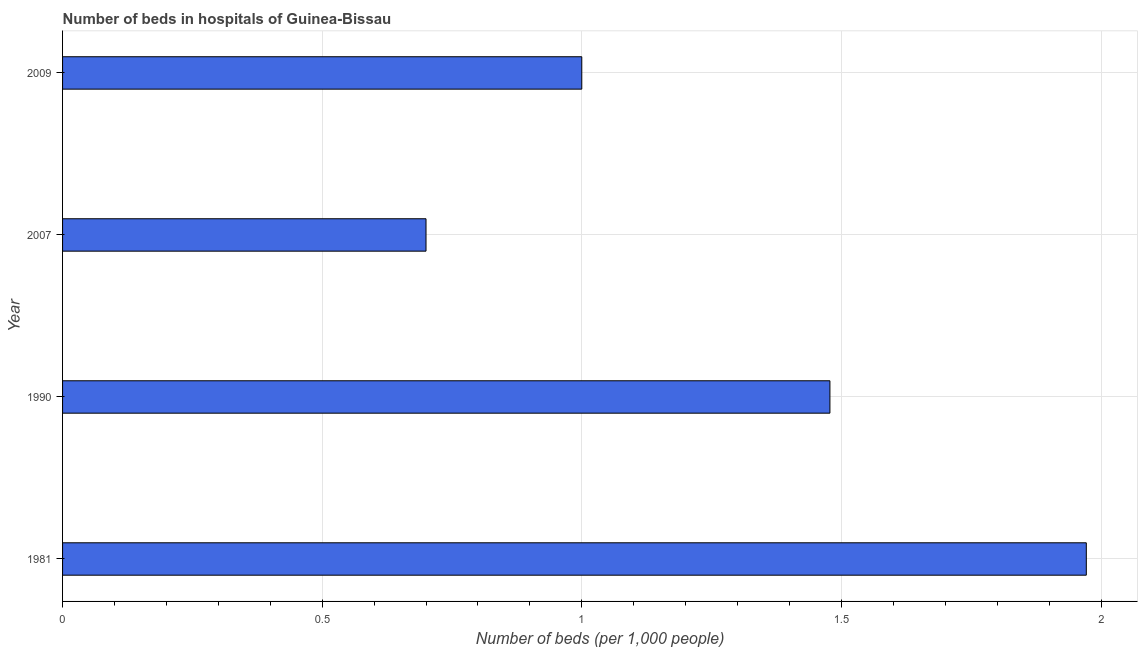Does the graph contain grids?
Keep it short and to the point. Yes. What is the title of the graph?
Your answer should be compact. Number of beds in hospitals of Guinea-Bissau. What is the label or title of the X-axis?
Provide a succinct answer. Number of beds (per 1,0 people). What is the number of hospital beds in 1981?
Offer a terse response. 1.97. Across all years, what is the maximum number of hospital beds?
Ensure brevity in your answer.  1.97. In which year was the number of hospital beds maximum?
Ensure brevity in your answer.  1981. What is the sum of the number of hospital beds?
Offer a terse response. 5.15. What is the difference between the number of hospital beds in 1990 and 2007?
Provide a succinct answer. 0.78. What is the average number of hospital beds per year?
Offer a very short reply. 1.29. What is the median number of hospital beds?
Give a very brief answer. 1.24. In how many years, is the number of hospital beds greater than 1.4 %?
Offer a terse response. 2. What is the ratio of the number of hospital beds in 1990 to that in 2007?
Give a very brief answer. 2.11. Is the number of hospital beds in 1981 less than that in 2009?
Make the answer very short. No. Is the difference between the number of hospital beds in 1981 and 1990 greater than the difference between any two years?
Provide a short and direct response. No. What is the difference between the highest and the second highest number of hospital beds?
Keep it short and to the point. 0.49. Is the sum of the number of hospital beds in 1981 and 2007 greater than the maximum number of hospital beds across all years?
Your answer should be compact. Yes. What is the difference between the highest and the lowest number of hospital beds?
Provide a succinct answer. 1.27. In how many years, is the number of hospital beds greater than the average number of hospital beds taken over all years?
Ensure brevity in your answer.  2. How many bars are there?
Make the answer very short. 4. Are all the bars in the graph horizontal?
Offer a terse response. Yes. How many years are there in the graph?
Your answer should be compact. 4. Are the values on the major ticks of X-axis written in scientific E-notation?
Keep it short and to the point. No. What is the Number of beds (per 1,000 people) of 1981?
Provide a succinct answer. 1.97. What is the Number of beds (per 1,000 people) in 1990?
Make the answer very short. 1.48. What is the Number of beds (per 1,000 people) of 2007?
Offer a terse response. 0.7. What is the Number of beds (per 1,000 people) of 2009?
Provide a short and direct response. 1. What is the difference between the Number of beds (per 1,000 people) in 1981 and 1990?
Give a very brief answer. 0.49. What is the difference between the Number of beds (per 1,000 people) in 1981 and 2007?
Offer a very short reply. 1.27. What is the difference between the Number of beds (per 1,000 people) in 1981 and 2009?
Offer a very short reply. 0.97. What is the difference between the Number of beds (per 1,000 people) in 1990 and 2007?
Make the answer very short. 0.78. What is the difference between the Number of beds (per 1,000 people) in 1990 and 2009?
Give a very brief answer. 0.48. What is the ratio of the Number of beds (per 1,000 people) in 1981 to that in 1990?
Offer a terse response. 1.33. What is the ratio of the Number of beds (per 1,000 people) in 1981 to that in 2007?
Offer a terse response. 2.82. What is the ratio of the Number of beds (per 1,000 people) in 1981 to that in 2009?
Your answer should be compact. 1.97. What is the ratio of the Number of beds (per 1,000 people) in 1990 to that in 2007?
Offer a terse response. 2.11. What is the ratio of the Number of beds (per 1,000 people) in 1990 to that in 2009?
Ensure brevity in your answer.  1.48. 